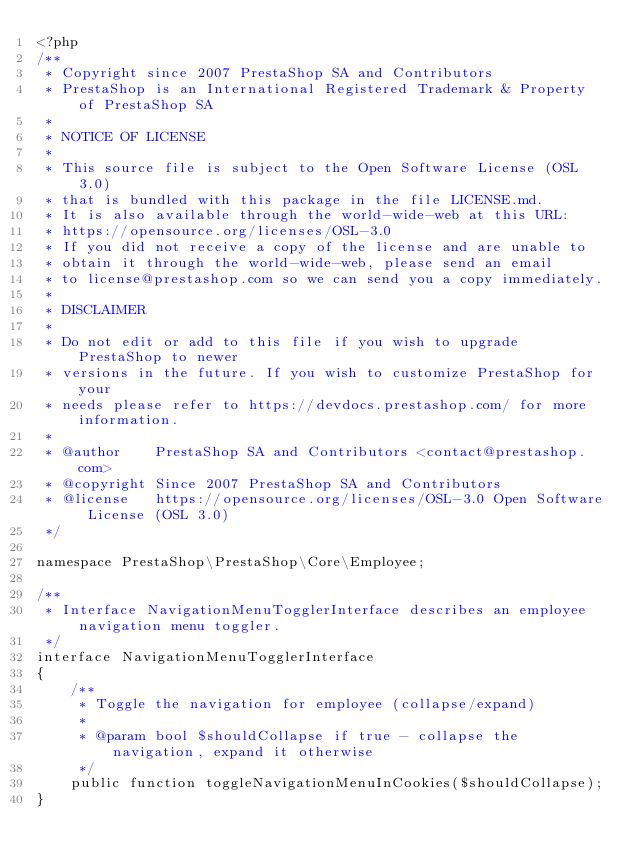<code> <loc_0><loc_0><loc_500><loc_500><_PHP_><?php
/**
 * Copyright since 2007 PrestaShop SA and Contributors
 * PrestaShop is an International Registered Trademark & Property of PrestaShop SA
 *
 * NOTICE OF LICENSE
 *
 * This source file is subject to the Open Software License (OSL 3.0)
 * that is bundled with this package in the file LICENSE.md.
 * It is also available through the world-wide-web at this URL:
 * https://opensource.org/licenses/OSL-3.0
 * If you did not receive a copy of the license and are unable to
 * obtain it through the world-wide-web, please send an email
 * to license@prestashop.com so we can send you a copy immediately.
 *
 * DISCLAIMER
 *
 * Do not edit or add to this file if you wish to upgrade PrestaShop to newer
 * versions in the future. If you wish to customize PrestaShop for your
 * needs please refer to https://devdocs.prestashop.com/ for more information.
 *
 * @author    PrestaShop SA and Contributors <contact@prestashop.com>
 * @copyright Since 2007 PrestaShop SA and Contributors
 * @license   https://opensource.org/licenses/OSL-3.0 Open Software License (OSL 3.0)
 */

namespace PrestaShop\PrestaShop\Core\Employee;

/**
 * Interface NavigationMenuTogglerInterface describes an employee navigation menu toggler.
 */
interface NavigationMenuTogglerInterface
{
    /**
     * Toggle the navigation for employee (collapse/expand)
     *
     * @param bool $shouldCollapse if true - collapse the navigation, expand it otherwise
     */
    public function toggleNavigationMenuInCookies($shouldCollapse);
}
</code> 